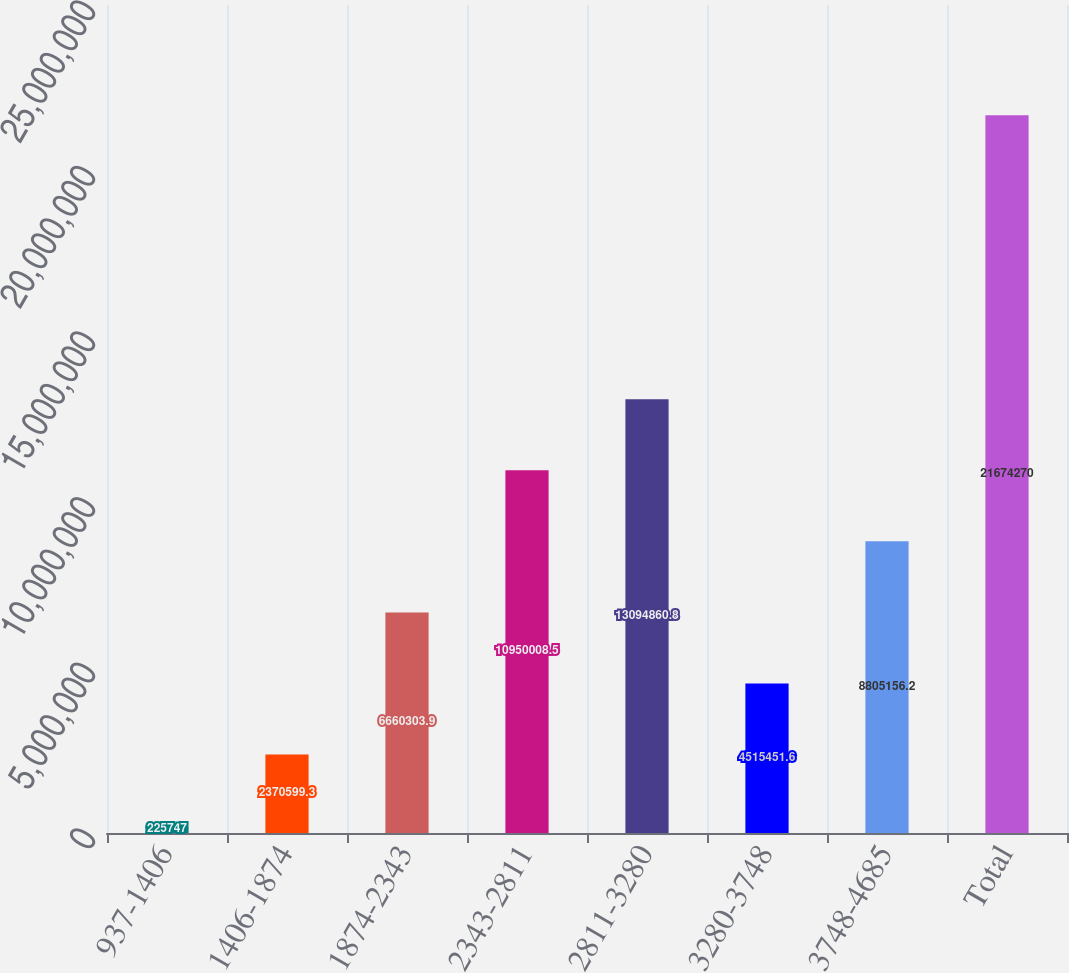Convert chart. <chart><loc_0><loc_0><loc_500><loc_500><bar_chart><fcel>937-1406<fcel>1406-1874<fcel>1874-2343<fcel>2343-2811<fcel>2811-3280<fcel>3280-3748<fcel>3748-4685<fcel>Total<nl><fcel>225747<fcel>2.3706e+06<fcel>6.6603e+06<fcel>1.095e+07<fcel>1.30949e+07<fcel>4.51545e+06<fcel>8.80516e+06<fcel>2.16743e+07<nl></chart> 